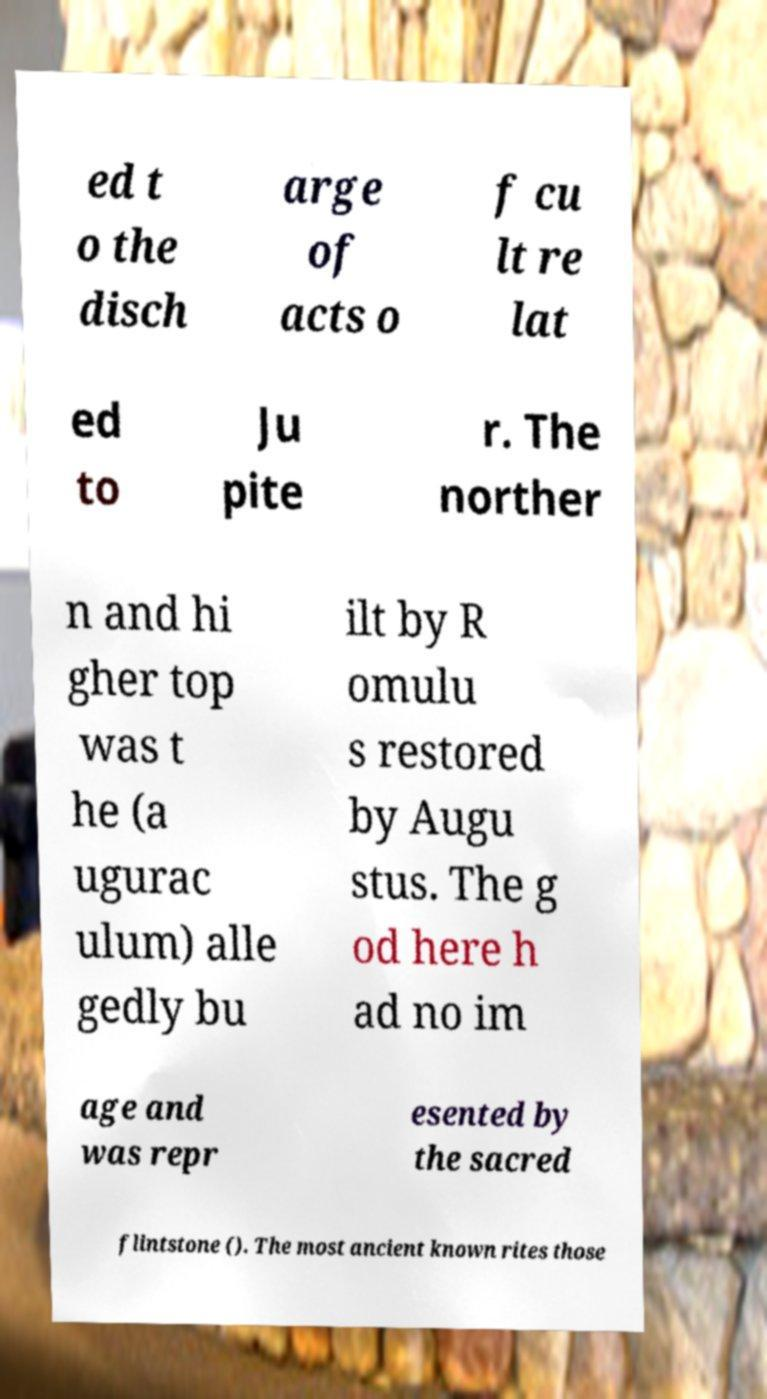Could you extract and type out the text from this image? ed t o the disch arge of acts o f cu lt re lat ed to Ju pite r. The norther n and hi gher top was t he (a ugurac ulum) alle gedly bu ilt by R omulu s restored by Augu stus. The g od here h ad no im age and was repr esented by the sacred flintstone (). The most ancient known rites those 